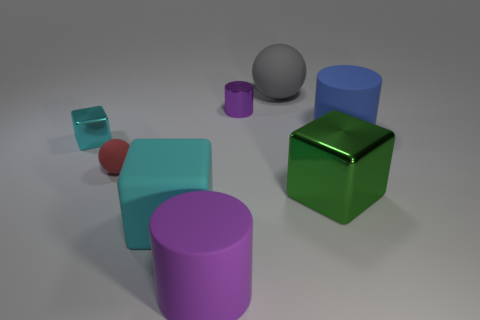What is the material of the large block that is the same color as the tiny cube?
Give a very brief answer. Rubber. What is the size of the other cube that is the same color as the tiny metal block?
Provide a short and direct response. Large. Is the shape of the small cyan metallic object the same as the purple thing behind the large purple cylinder?
Ensure brevity in your answer.  No. Are there any small yellow objects of the same shape as the blue thing?
Give a very brief answer. No. What shape is the large metal object that is in front of the tiny metal thing to the left of the purple matte cylinder?
Your response must be concise. Cube. The thing on the left side of the tiny red matte sphere has what shape?
Give a very brief answer. Cube. There is a object to the left of the small red object; is its color the same as the big matte thing that is on the right side of the gray ball?
Give a very brief answer. No. What number of small objects are both to the right of the small cyan metallic cube and on the left side of the purple metal object?
Make the answer very short. 1. What is the size of the other cube that is made of the same material as the green cube?
Ensure brevity in your answer.  Small. How big is the red matte object?
Offer a very short reply. Small. 